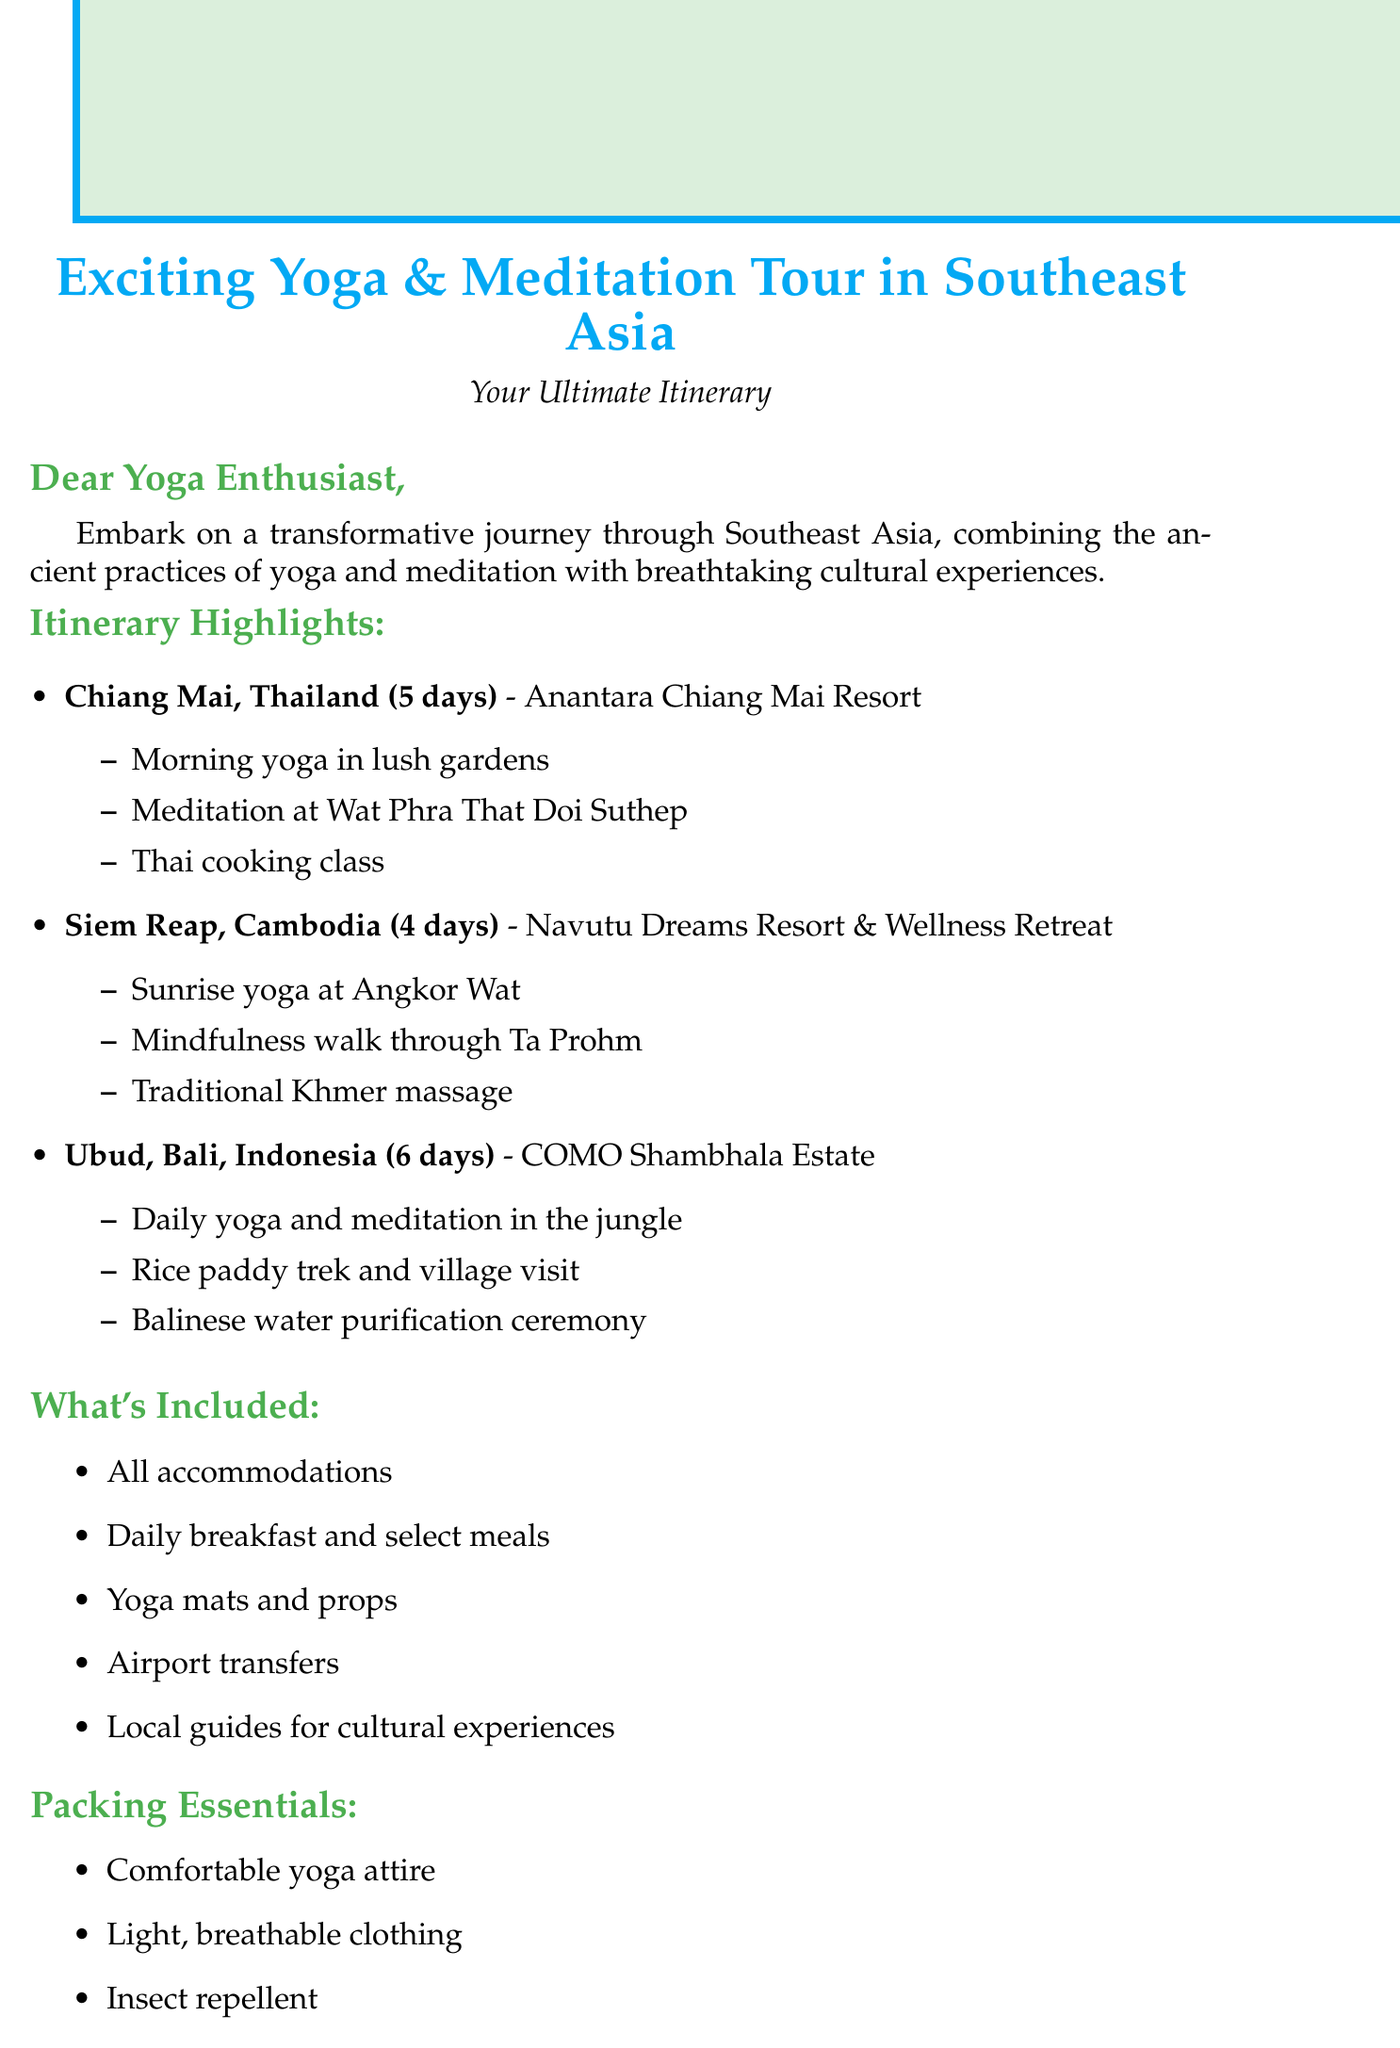What is the duration of the yoga tour in Chiang Mai? The duration of the yoga tour in Chiang Mai is specified in the itinerary section of the document.
Answer: 5 days What is the first location mentioned in the itinerary? The first location listed in the itinerary highlights is the starting point of the tour.
Answer: Chiang Mai, Thailand What kind of accommodation is provided in Siem Reap? The document lists accommodations for each destination, with specific names for the resorts.
Answer: Navutu Dreams Resort & Wellness Retreat How many days will participants spend in Ubud? The duration for Ubud is given in the document, making it easy to identify the number of days.
Answer: 6 days What activity is scheduled at Angkor Wat? The document highlights specific activities planned at each destination, including that at Angkor Wat.
Answer: Sunrise yoga Which essential item is specifically mentioned for self-reflection? The packing essentials section includes items that should be brought, with one explicitly for reflection.
Answer: Journal What type of massage experience is offered in Siem Reap? The highlights for each location includes unique local experiences available, which mention the type of massage in Siem Reap.
Answer: Traditional Khmer massage What is the last note included in the email? The closing note provides a final message summarizing the experience, emphasizing the aspect of the journey.
Answer: Namaste, Your Digital Nomad Yoga Guide 